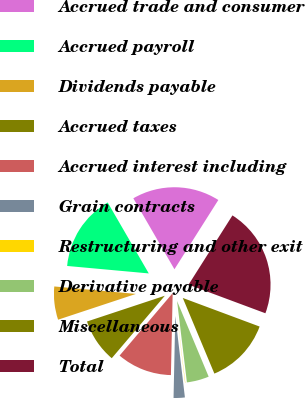Convert chart. <chart><loc_0><loc_0><loc_500><loc_500><pie_chart><fcel>Accrued trade and consumer<fcel>Accrued payroll<fcel>Dividends payable<fcel>Accrued taxes<fcel>Accrued interest including<fcel>Grain contracts<fcel>Restructuring and other exit<fcel>Derivative payable<fcel>Miscellaneous<fcel>Total<nl><fcel>17.35%<fcel>15.19%<fcel>6.54%<fcel>8.7%<fcel>10.87%<fcel>2.21%<fcel>0.05%<fcel>4.38%<fcel>13.03%<fcel>21.68%<nl></chart> 